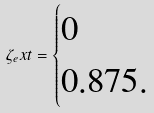Convert formula to latex. <formula><loc_0><loc_0><loc_500><loc_500>\zeta _ { e } x t = \begin{cases} 0 \\ 0 . 8 7 5 . \end{cases}</formula> 